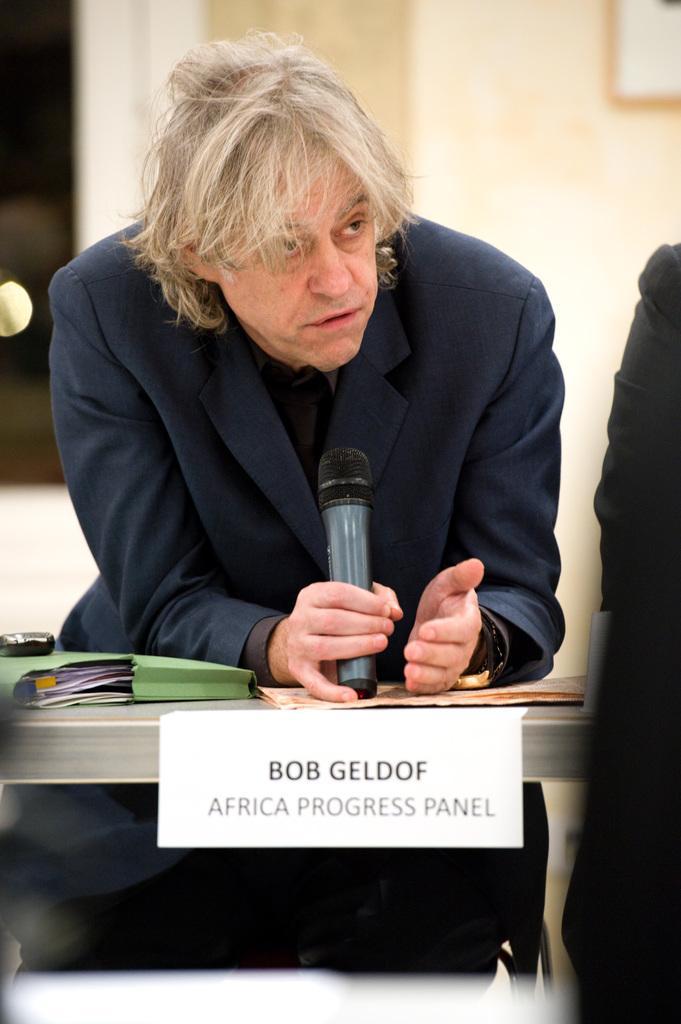Can you describe this image briefly? There is a man sitting on a chair. He is wearing a suit and he is speaking on a microphone. This is a table where a file is placed on it and name plate stick to it. 